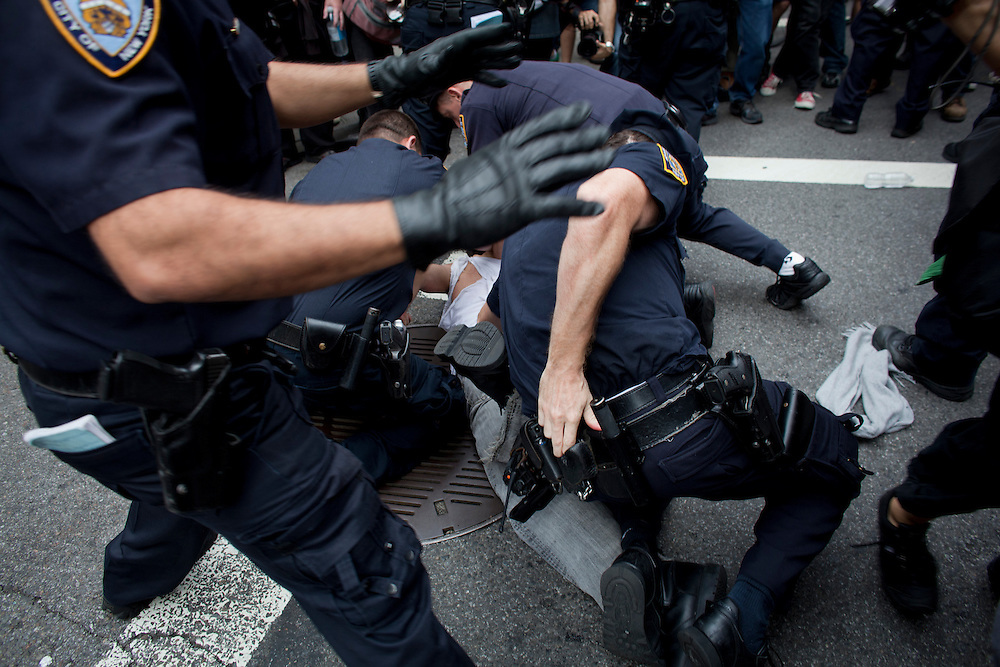What can you infer about the roles or affiliations of the people in this image? The uniforms and gear worn by the majority of individuals in the image suggest that they are law enforcement officers. They are wearing dark, standardized clothing typically associated with police forces. The individual being subdued appears to be a civilian, based on their casual clothing. This visual context suggests a scenario involving law enforcement detaining a civilian, likely in response to an incident requiring police intervention. Why might this incident have required such a strong police presence? The substantial police presence could indicate that the incident necessitated a forceful response, potentially due to the scale of the event or the behavior of individuals involved. Situations such as protests, large public disturbances, or incidents posing a significant threat to public safety often require numerous officers to ensure control and safety. The image shows multiple officers actively engaged, which could suggest that the situation was deemed high-risk or demanded a coordinated police response. Describe the emotions that might be experienced by the individuals in this image. In high-tension scenarios like the one depicted, the subdued individual might be experiencing fear, distress, or anxiety due to the physical and authoritative handling by the police. The officers involved may be feeling a range of emotions from intense focus and professionalism to stress and urgency, depending on the nature and context of the incident. Observers or other civilians nearby might be experiencing a mix of concern, shock, or fear as they witness the event unfold. 